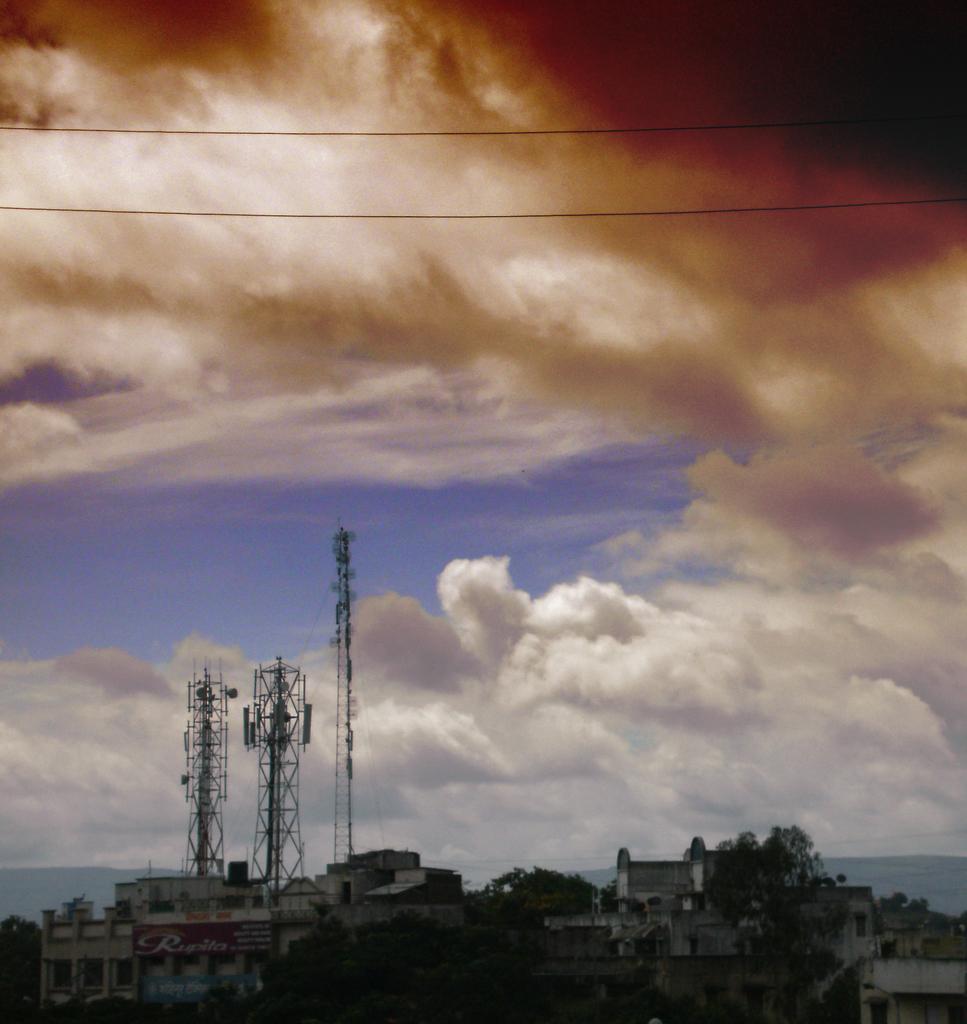Please provide a concise description of this image. There are some trees and buildings are present at the bottom of this image. There are three towers present on the left side of this image, and there is a cloudy sky in the background. 